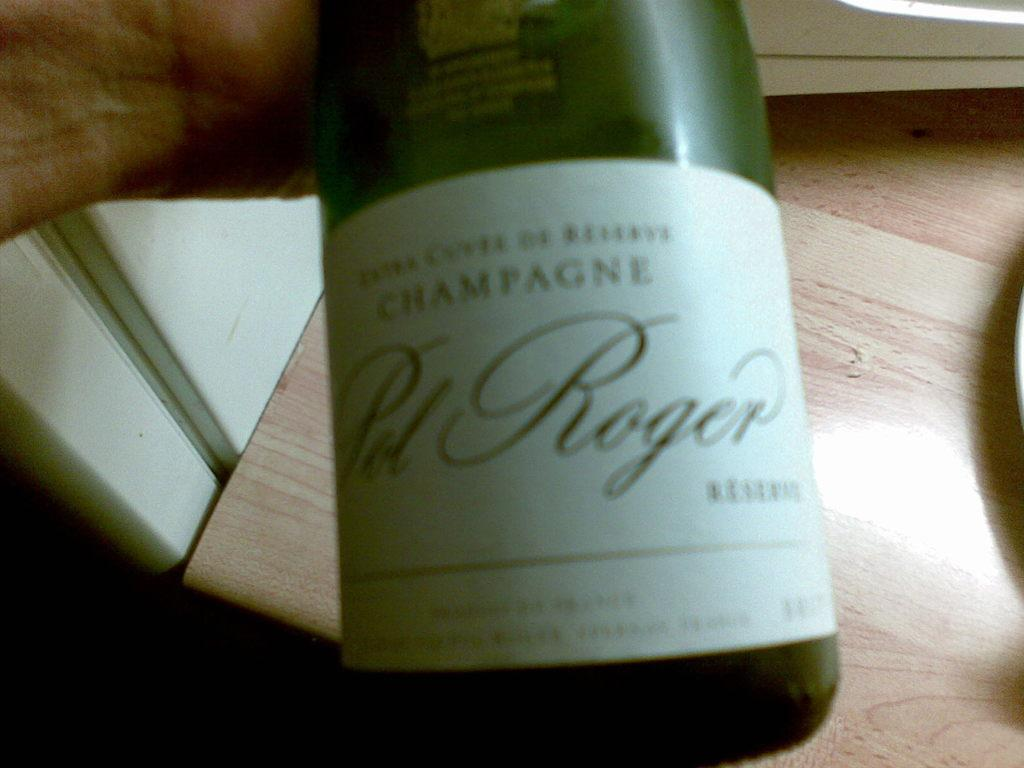<image>
Summarize the visual content of the image. A person is holding a bottle of Pal Roger champagne. 